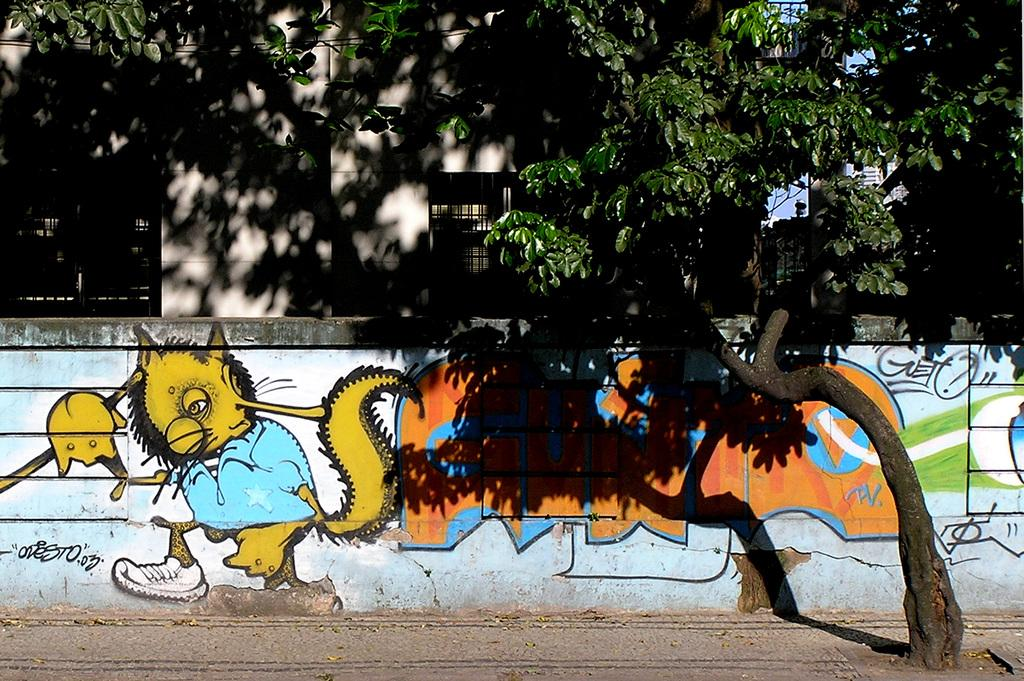What is hanging on the wall in the image? There is a painting on the wall in the image. What type of natural element can be seen in the image? There is a tree visible in the image. What type of structure is visible in the background of the image? There is a building in the background of the image. Can you tell me how many socks are hanging from the tree in the image? There are no socks present in the image; it features a painting on the wall, a tree, and a building in the background. Is there a fire visible in the image? There is no fire present in the image. 